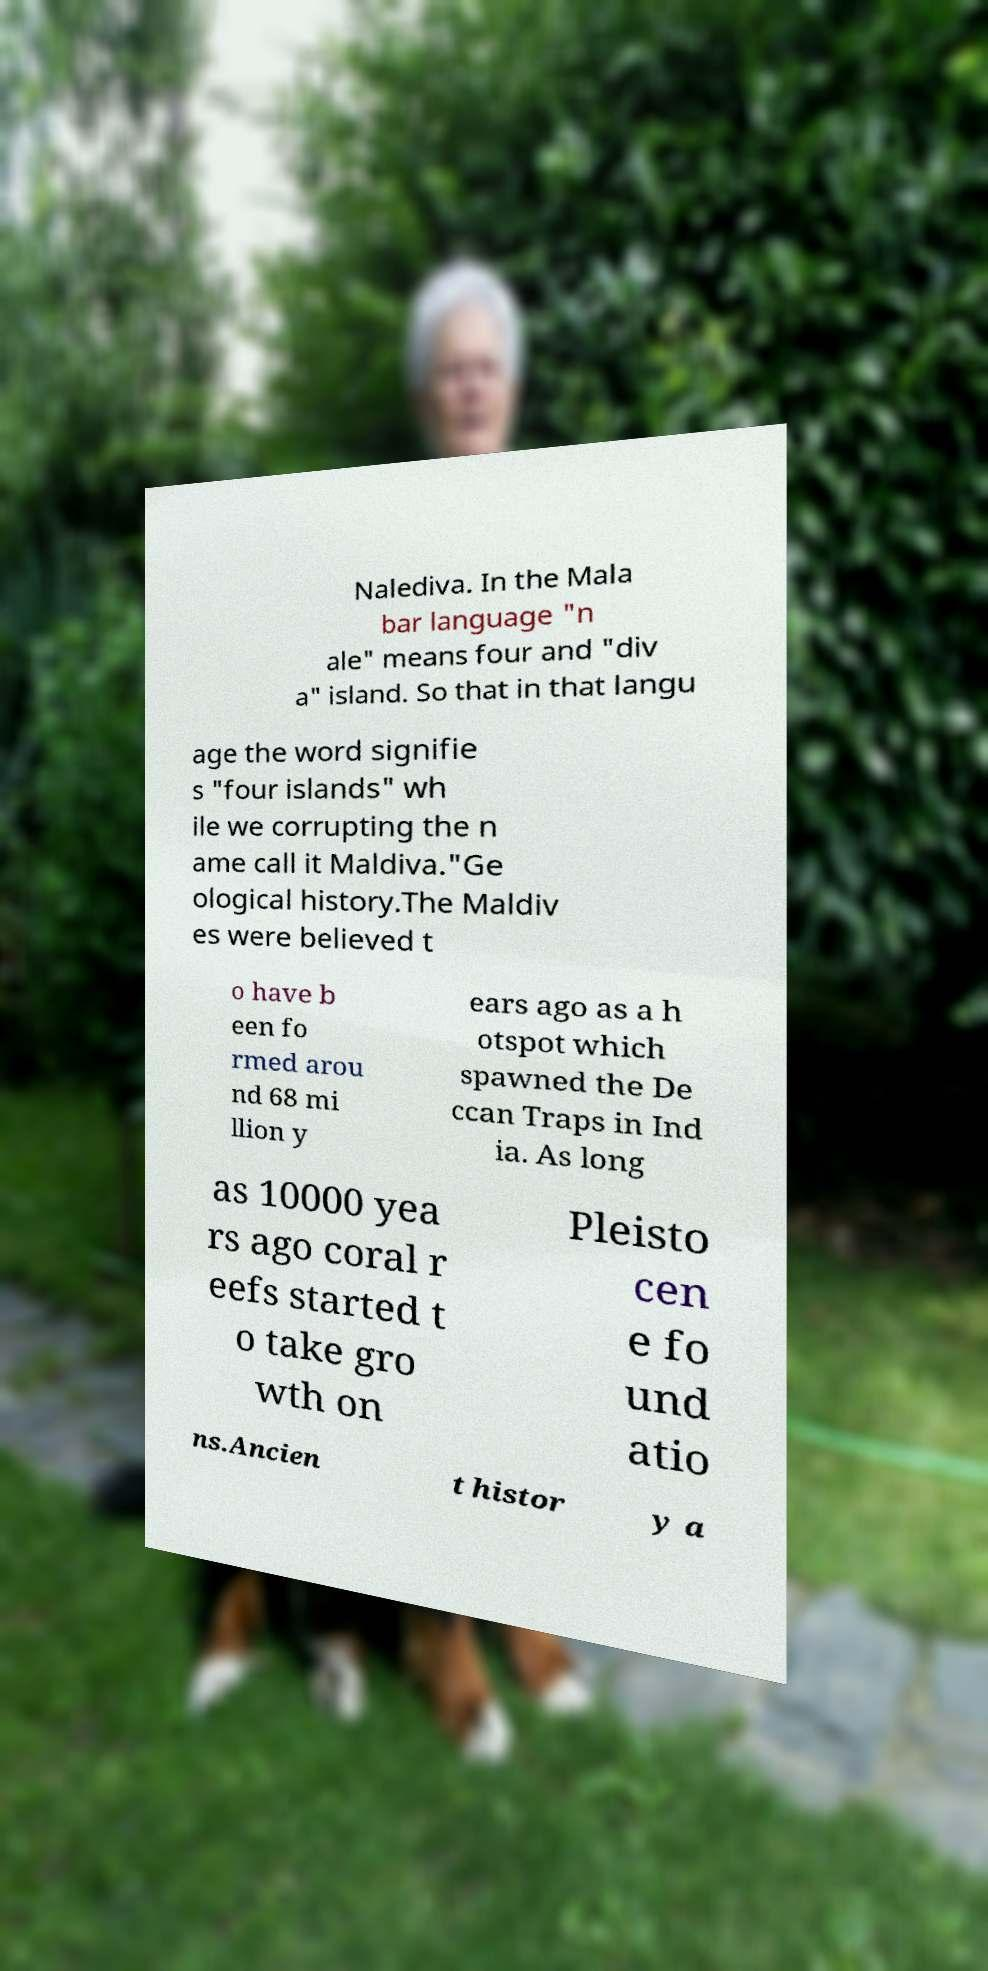Can you read and provide the text displayed in the image?This photo seems to have some interesting text. Can you extract and type it out for me? Nalediva. In the Mala bar language "n ale" means four and "div a" island. So that in that langu age the word signifie s "four islands" wh ile we corrupting the n ame call it Maldiva."Ge ological history.The Maldiv es were believed t o have b een fo rmed arou nd 68 mi llion y ears ago as a h otspot which spawned the De ccan Traps in Ind ia. As long as 10000 yea rs ago coral r eefs started t o take gro wth on Pleisto cen e fo und atio ns.Ancien t histor y a 